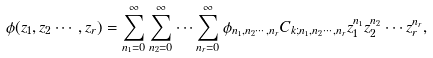<formula> <loc_0><loc_0><loc_500><loc_500>\phi ( z _ { 1 } , z _ { 2 } \cdots , z _ { r } ) = \sum _ { n _ { 1 } = 0 } ^ { \infty } \sum _ { n _ { 2 } = 0 } ^ { \infty } \cdots \sum _ { n _ { r } = 0 } ^ { \infty } \phi _ { n _ { 1 } , n _ { 2 } \cdots , n _ { r } } C _ { k ; n _ { 1 } , n _ { 2 } \cdots , n _ { r } } z _ { 1 } ^ { n _ { 1 } } z _ { 2 } ^ { n _ { 2 } } \cdots z _ { r } ^ { n _ { r } } ,</formula> 